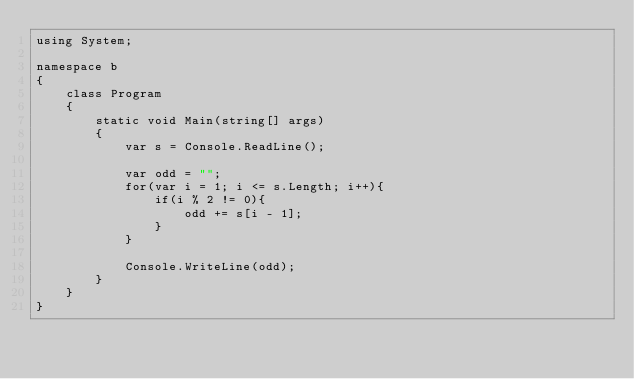<code> <loc_0><loc_0><loc_500><loc_500><_C#_>using System;

namespace b
{
    class Program
    {
        static void Main(string[] args)
        {
            var s = Console.ReadLine();

            var odd = "";
            for(var i = 1; i <= s.Length; i++){
                if(i % 2 != 0){
                    odd += s[i - 1];
                }
            }

            Console.WriteLine(odd);
        }
    }
}
</code> 